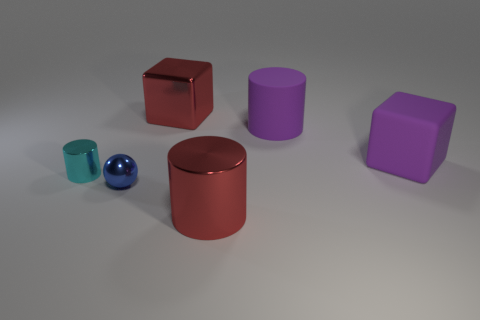Subtract all gray cubes. Subtract all purple balls. How many cubes are left? 2 Subtract all brown blocks. How many purple balls are left? 0 Add 1 small cyans. How many big things exist? 0 Subtract all big metallic things. Subtract all tiny cylinders. How many objects are left? 3 Add 1 red metallic blocks. How many red metallic blocks are left? 2 Add 5 tiny balls. How many tiny balls exist? 6 Add 3 tiny matte objects. How many objects exist? 9 Subtract all cyan cylinders. How many cylinders are left? 2 Subtract all purple matte cylinders. How many cylinders are left? 2 Subtract 1 purple cubes. How many objects are left? 5 